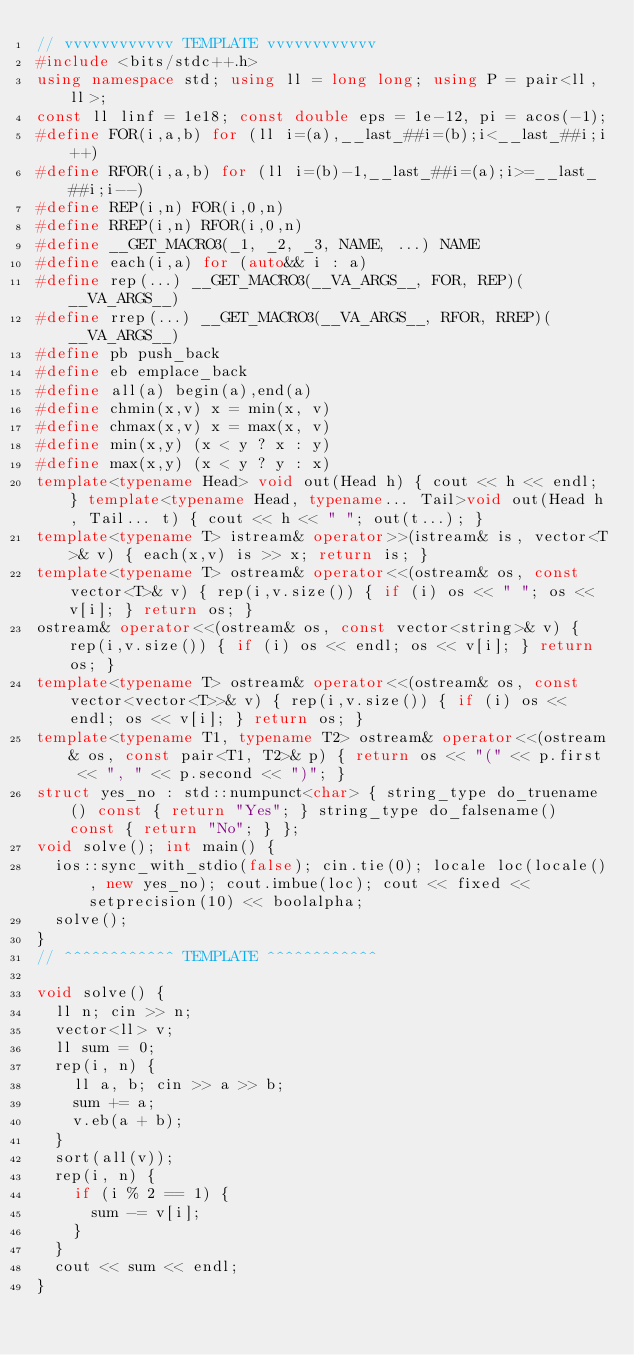<code> <loc_0><loc_0><loc_500><loc_500><_C++_>// vvvvvvvvvvvv TEMPLATE vvvvvvvvvvvv
#include <bits/stdc++.h>
using namespace std; using ll = long long; using P = pair<ll, ll>;
const ll linf = 1e18; const double eps = 1e-12, pi = acos(-1);
#define FOR(i,a,b) for (ll i=(a),__last_##i=(b);i<__last_##i;i++)
#define RFOR(i,a,b) for (ll i=(b)-1,__last_##i=(a);i>=__last_##i;i--)
#define REP(i,n) FOR(i,0,n)
#define RREP(i,n) RFOR(i,0,n)
#define __GET_MACRO3(_1, _2, _3, NAME, ...) NAME
#define each(i,a) for (auto&& i : a)
#define rep(...) __GET_MACRO3(__VA_ARGS__, FOR, REP)(__VA_ARGS__)
#define rrep(...) __GET_MACRO3(__VA_ARGS__, RFOR, RREP)(__VA_ARGS__)
#define pb push_back
#define eb emplace_back
#define all(a) begin(a),end(a)
#define chmin(x,v) x = min(x, v)
#define chmax(x,v) x = max(x, v)
#define min(x,y) (x < y ? x : y)
#define max(x,y) (x < y ? y : x)
template<typename Head> void out(Head h) { cout << h << endl; } template<typename Head, typename... Tail>void out(Head h, Tail... t) { cout << h << " "; out(t...); }
template<typename T> istream& operator>>(istream& is, vector<T>& v) { each(x,v) is >> x; return is; }
template<typename T> ostream& operator<<(ostream& os, const vector<T>& v) { rep(i,v.size()) { if (i) os << " "; os << v[i]; } return os; }
ostream& operator<<(ostream& os, const vector<string>& v) { rep(i,v.size()) { if (i) os << endl; os << v[i]; } return os; }
template<typename T> ostream& operator<<(ostream& os, const vector<vector<T>>& v) { rep(i,v.size()) { if (i) os << endl; os << v[i]; } return os; }
template<typename T1, typename T2> ostream& operator<<(ostream& os, const pair<T1, T2>& p) { return os << "(" << p.first << ", " << p.second << ")"; }
struct yes_no : std::numpunct<char> { string_type do_truename() const { return "Yes"; } string_type do_falsename() const { return "No"; } };
void solve(); int main() {
  ios::sync_with_stdio(false); cin.tie(0); locale loc(locale(), new yes_no); cout.imbue(loc); cout << fixed << setprecision(10) << boolalpha;
  solve();
}
// ^^^^^^^^^^^^ TEMPLATE ^^^^^^^^^^^^

void solve() {
  ll n; cin >> n;
  vector<ll> v;
  ll sum = 0;
  rep(i, n) {
    ll a, b; cin >> a >> b;
    sum += a;
    v.eb(a + b);
  }
  sort(all(v));
  rep(i, n) {
    if (i % 2 == 1) {
      sum -= v[i];
    }
  }
  cout << sum << endl;
}
</code> 